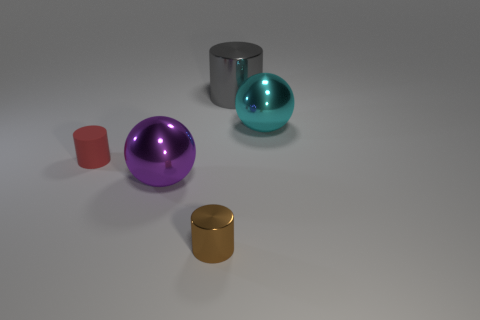Add 2 big gray shiny cylinders. How many objects exist? 7 Subtract all tiny rubber cylinders. How many cylinders are left? 2 Subtract all brown cylinders. How many cylinders are left? 2 Subtract 0 blue cylinders. How many objects are left? 5 Subtract all cylinders. How many objects are left? 2 Subtract 1 cylinders. How many cylinders are left? 2 Subtract all gray balls. Subtract all purple cylinders. How many balls are left? 2 Subtract all red cylinders. How many purple balls are left? 1 Subtract all purple metal blocks. Subtract all large balls. How many objects are left? 3 Add 1 red cylinders. How many red cylinders are left? 2 